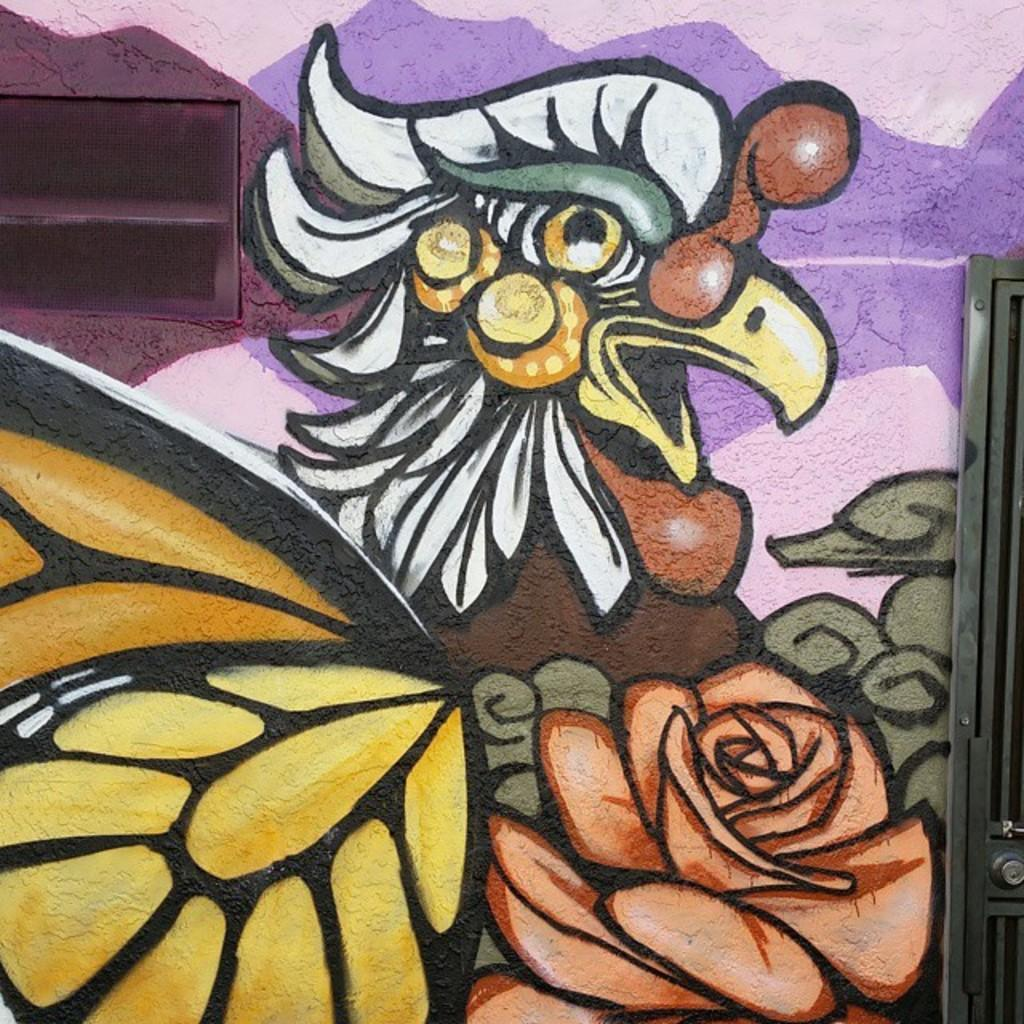What is on the wall in the image? There is a colorful painting on the wall in the image. What can be seen on both sides of the image? There are objects on both sides of the image. How many cents are visible on the painting in the image? There are no cents visible on the painting in the image. Is there a bike in the image? There is no mention of a bike in the provided facts, so it cannot be determined if one is present in the image. 